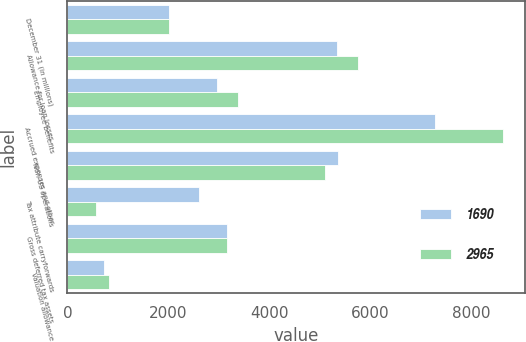<chart> <loc_0><loc_0><loc_500><loc_500><stacked_bar_chart><ecel><fcel>December 31 (in millions)<fcel>Allowance for loan losses<fcel>Employee benefits<fcel>Accrued expenses and other<fcel>Non-US operations<fcel>Tax attribute carryforwards<fcel>Gross deferred tax assets<fcel>Valuation allowance<nl><fcel>1690<fcel>2015<fcel>5343<fcel>2972<fcel>7299<fcel>5365<fcel>2602<fcel>3175<fcel>735<nl><fcel>2965<fcel>2014<fcel>5756<fcel>3378<fcel>8637<fcel>5106<fcel>570<fcel>3175<fcel>820<nl></chart> 